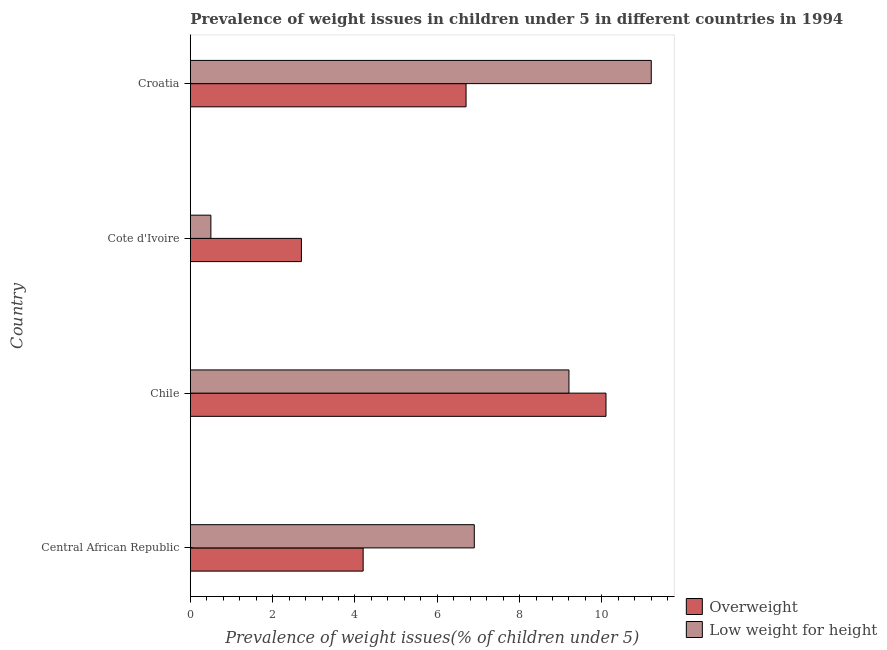How many different coloured bars are there?
Offer a terse response. 2. How many groups of bars are there?
Offer a terse response. 4. Are the number of bars per tick equal to the number of legend labels?
Make the answer very short. Yes. How many bars are there on the 1st tick from the bottom?
Your answer should be very brief. 2. What is the label of the 1st group of bars from the top?
Provide a succinct answer. Croatia. In how many cases, is the number of bars for a given country not equal to the number of legend labels?
Keep it short and to the point. 0. What is the percentage of underweight children in Central African Republic?
Your response must be concise. 6.9. Across all countries, what is the maximum percentage of underweight children?
Ensure brevity in your answer.  11.2. Across all countries, what is the minimum percentage of underweight children?
Ensure brevity in your answer.  0.5. In which country was the percentage of underweight children maximum?
Provide a short and direct response. Croatia. In which country was the percentage of underweight children minimum?
Your response must be concise. Cote d'Ivoire. What is the total percentage of underweight children in the graph?
Offer a terse response. 27.8. What is the difference between the percentage of underweight children in Central African Republic and that in Croatia?
Make the answer very short. -4.3. What is the average percentage of underweight children per country?
Give a very brief answer. 6.95. What is the ratio of the percentage of overweight children in Central African Republic to that in Chile?
Keep it short and to the point. 0.42. Is the percentage of overweight children in Cote d'Ivoire less than that in Croatia?
Offer a terse response. Yes. Is the difference between the percentage of underweight children in Central African Republic and Cote d'Ivoire greater than the difference between the percentage of overweight children in Central African Republic and Cote d'Ivoire?
Ensure brevity in your answer.  Yes. What is the difference between the highest and the second highest percentage of overweight children?
Your answer should be very brief. 3.4. What is the difference between the highest and the lowest percentage of underweight children?
Your answer should be very brief. 10.7. In how many countries, is the percentage of overweight children greater than the average percentage of overweight children taken over all countries?
Your answer should be very brief. 2. Is the sum of the percentage of underweight children in Chile and Croatia greater than the maximum percentage of overweight children across all countries?
Ensure brevity in your answer.  Yes. What does the 1st bar from the top in Cote d'Ivoire represents?
Your response must be concise. Low weight for height. What does the 1st bar from the bottom in Central African Republic represents?
Make the answer very short. Overweight. Are all the bars in the graph horizontal?
Provide a short and direct response. Yes. How many countries are there in the graph?
Make the answer very short. 4. What is the difference between two consecutive major ticks on the X-axis?
Make the answer very short. 2. Are the values on the major ticks of X-axis written in scientific E-notation?
Your response must be concise. No. Does the graph contain any zero values?
Provide a short and direct response. No. What is the title of the graph?
Your answer should be compact. Prevalence of weight issues in children under 5 in different countries in 1994. Does "Overweight" appear as one of the legend labels in the graph?
Ensure brevity in your answer.  Yes. What is the label or title of the X-axis?
Provide a short and direct response. Prevalence of weight issues(% of children under 5). What is the label or title of the Y-axis?
Your answer should be very brief. Country. What is the Prevalence of weight issues(% of children under 5) of Overweight in Central African Republic?
Keep it short and to the point. 4.2. What is the Prevalence of weight issues(% of children under 5) in Low weight for height in Central African Republic?
Offer a terse response. 6.9. What is the Prevalence of weight issues(% of children under 5) of Overweight in Chile?
Keep it short and to the point. 10.1. What is the Prevalence of weight issues(% of children under 5) in Low weight for height in Chile?
Offer a very short reply. 9.2. What is the Prevalence of weight issues(% of children under 5) of Overweight in Cote d'Ivoire?
Keep it short and to the point. 2.7. What is the Prevalence of weight issues(% of children under 5) in Low weight for height in Cote d'Ivoire?
Provide a succinct answer. 0.5. What is the Prevalence of weight issues(% of children under 5) of Overweight in Croatia?
Make the answer very short. 6.7. What is the Prevalence of weight issues(% of children under 5) of Low weight for height in Croatia?
Make the answer very short. 11.2. Across all countries, what is the maximum Prevalence of weight issues(% of children under 5) in Overweight?
Ensure brevity in your answer.  10.1. Across all countries, what is the maximum Prevalence of weight issues(% of children under 5) in Low weight for height?
Provide a succinct answer. 11.2. Across all countries, what is the minimum Prevalence of weight issues(% of children under 5) of Overweight?
Your answer should be very brief. 2.7. Across all countries, what is the minimum Prevalence of weight issues(% of children under 5) of Low weight for height?
Provide a short and direct response. 0.5. What is the total Prevalence of weight issues(% of children under 5) of Overweight in the graph?
Offer a very short reply. 23.7. What is the total Prevalence of weight issues(% of children under 5) in Low weight for height in the graph?
Make the answer very short. 27.8. What is the difference between the Prevalence of weight issues(% of children under 5) of Overweight in Central African Republic and that in Chile?
Your answer should be very brief. -5.9. What is the difference between the Prevalence of weight issues(% of children under 5) in Low weight for height in Central African Republic and that in Chile?
Your answer should be very brief. -2.3. What is the difference between the Prevalence of weight issues(% of children under 5) of Overweight in Central African Republic and that in Cote d'Ivoire?
Keep it short and to the point. 1.5. What is the difference between the Prevalence of weight issues(% of children under 5) in Overweight in Chile and that in Cote d'Ivoire?
Give a very brief answer. 7.4. What is the difference between the Prevalence of weight issues(% of children under 5) of Overweight in Chile and that in Croatia?
Your answer should be compact. 3.4. What is the difference between the Prevalence of weight issues(% of children under 5) of Overweight in Cote d'Ivoire and that in Croatia?
Your response must be concise. -4. What is the difference between the Prevalence of weight issues(% of children under 5) of Low weight for height in Cote d'Ivoire and that in Croatia?
Provide a short and direct response. -10.7. What is the difference between the Prevalence of weight issues(% of children under 5) of Overweight in Central African Republic and the Prevalence of weight issues(% of children under 5) of Low weight for height in Chile?
Your response must be concise. -5. What is the difference between the Prevalence of weight issues(% of children under 5) in Overweight in Central African Republic and the Prevalence of weight issues(% of children under 5) in Low weight for height in Croatia?
Offer a very short reply. -7. What is the difference between the Prevalence of weight issues(% of children under 5) in Overweight in Chile and the Prevalence of weight issues(% of children under 5) in Low weight for height in Cote d'Ivoire?
Your response must be concise. 9.6. What is the difference between the Prevalence of weight issues(% of children under 5) of Overweight in Cote d'Ivoire and the Prevalence of weight issues(% of children under 5) of Low weight for height in Croatia?
Make the answer very short. -8.5. What is the average Prevalence of weight issues(% of children under 5) of Overweight per country?
Your response must be concise. 5.92. What is the average Prevalence of weight issues(% of children under 5) of Low weight for height per country?
Offer a very short reply. 6.95. What is the difference between the Prevalence of weight issues(% of children under 5) in Overweight and Prevalence of weight issues(% of children under 5) in Low weight for height in Cote d'Ivoire?
Your answer should be very brief. 2.2. What is the ratio of the Prevalence of weight issues(% of children under 5) of Overweight in Central African Republic to that in Chile?
Provide a succinct answer. 0.42. What is the ratio of the Prevalence of weight issues(% of children under 5) of Low weight for height in Central African Republic to that in Chile?
Keep it short and to the point. 0.75. What is the ratio of the Prevalence of weight issues(% of children under 5) of Overweight in Central African Republic to that in Cote d'Ivoire?
Ensure brevity in your answer.  1.56. What is the ratio of the Prevalence of weight issues(% of children under 5) of Overweight in Central African Republic to that in Croatia?
Make the answer very short. 0.63. What is the ratio of the Prevalence of weight issues(% of children under 5) of Low weight for height in Central African Republic to that in Croatia?
Offer a very short reply. 0.62. What is the ratio of the Prevalence of weight issues(% of children under 5) of Overweight in Chile to that in Cote d'Ivoire?
Keep it short and to the point. 3.74. What is the ratio of the Prevalence of weight issues(% of children under 5) of Low weight for height in Chile to that in Cote d'Ivoire?
Your answer should be compact. 18.4. What is the ratio of the Prevalence of weight issues(% of children under 5) of Overweight in Chile to that in Croatia?
Make the answer very short. 1.51. What is the ratio of the Prevalence of weight issues(% of children under 5) in Low weight for height in Chile to that in Croatia?
Make the answer very short. 0.82. What is the ratio of the Prevalence of weight issues(% of children under 5) of Overweight in Cote d'Ivoire to that in Croatia?
Provide a short and direct response. 0.4. What is the ratio of the Prevalence of weight issues(% of children under 5) in Low weight for height in Cote d'Ivoire to that in Croatia?
Make the answer very short. 0.04. What is the difference between the highest and the second highest Prevalence of weight issues(% of children under 5) of Overweight?
Your answer should be very brief. 3.4. What is the difference between the highest and the lowest Prevalence of weight issues(% of children under 5) of Overweight?
Your response must be concise. 7.4. 